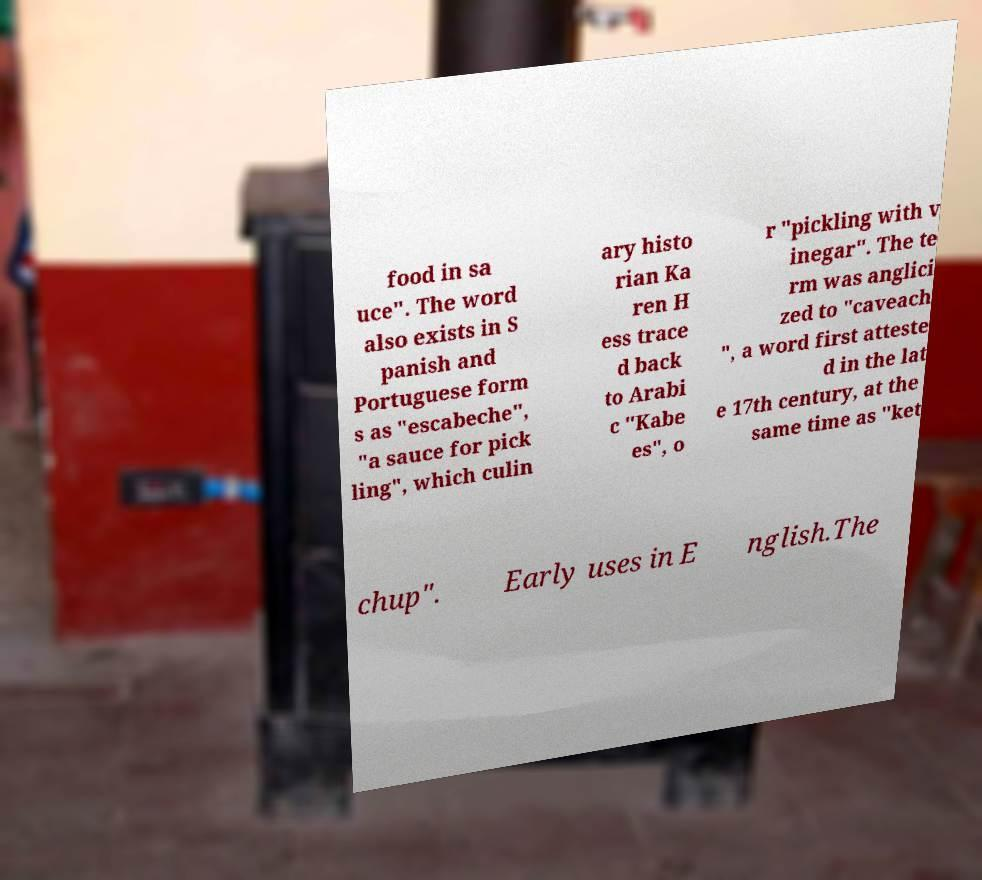Please read and relay the text visible in this image. What does it say? food in sa uce". The word also exists in S panish and Portuguese form s as "escabeche", "a sauce for pick ling", which culin ary histo rian Ka ren H ess trace d back to Arabi c "Kabe es", o r "pickling with v inegar". The te rm was anglici zed to "caveach ", a word first atteste d in the lat e 17th century, at the same time as "ket chup". Early uses in E nglish.The 